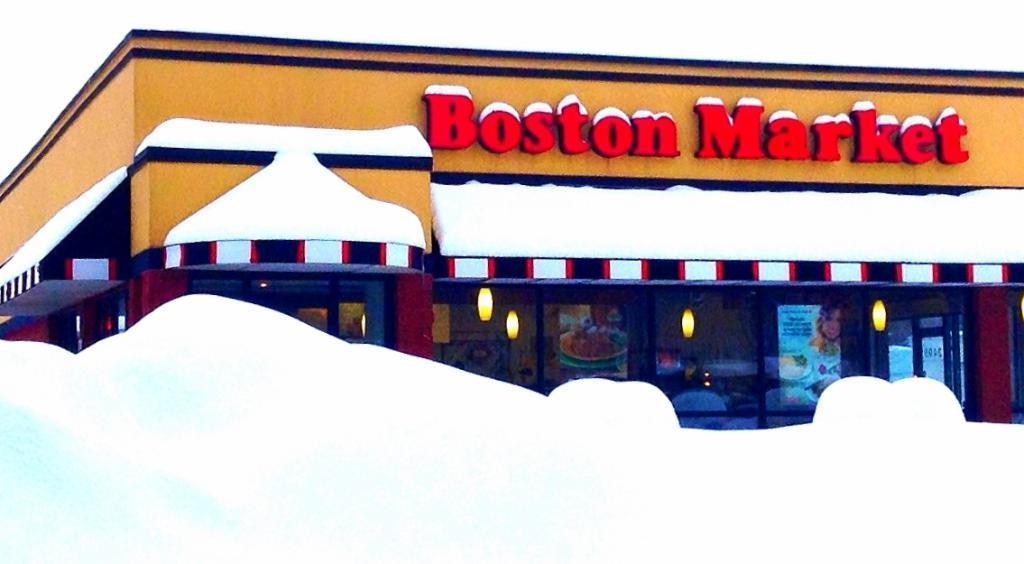Describe this image in one or two sentences. In this picture we can see a store, there is some text in the middle, we can see some glasses at the bottom, there are posters pasted on these glasses, we can also see lights. 